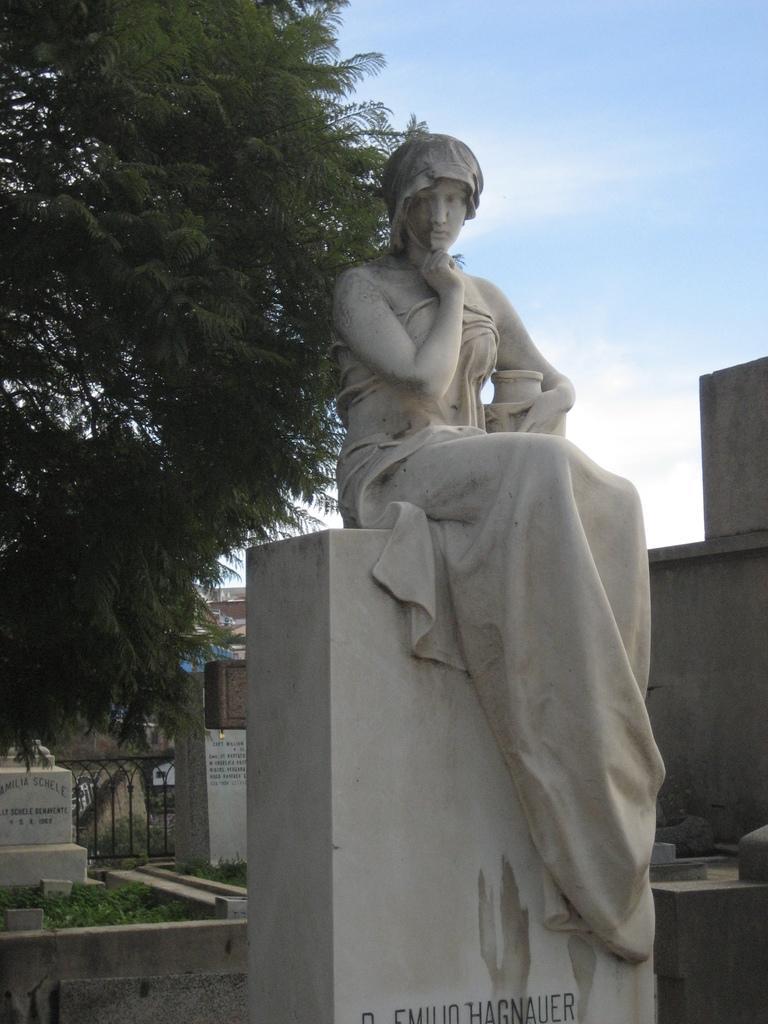Could you give a brief overview of what you see in this image? In this image we can see a statue. In the background, we can see the buildings. There is a tree on the left side of the image. We can see the sky at the top of the image. 